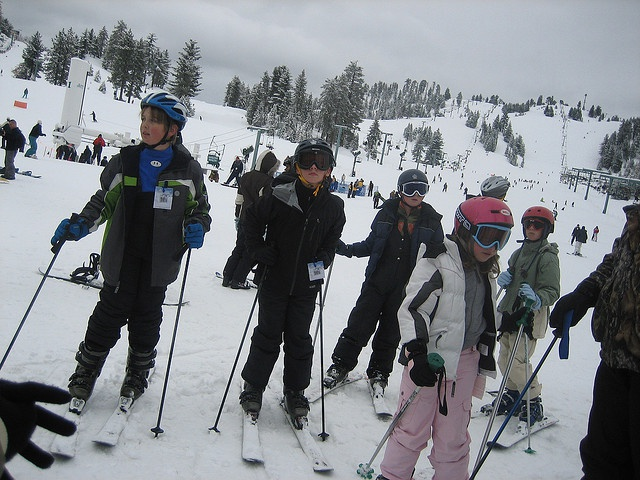Describe the objects in this image and their specific colors. I can see people in darkgray, black, navy, and gray tones, people in darkgray, gray, and black tones, people in darkgray, black, gray, and lightgray tones, people in darkgray, black, and gray tones, and people in darkgray, gray, black, and lightgray tones in this image. 